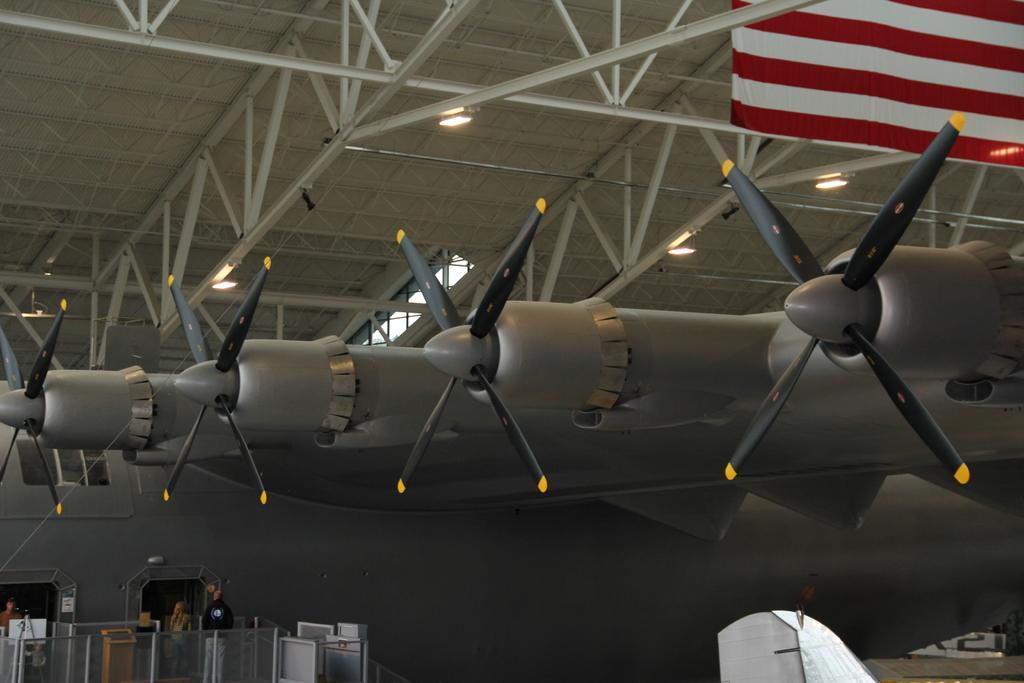In one or two sentences, can you explain what this image depicts? In the image we can see a plane. At the top of the image there is roof and there are some lights. In the bottom left corner of the image there is fencing. Behind the fencing two persons are standing. 